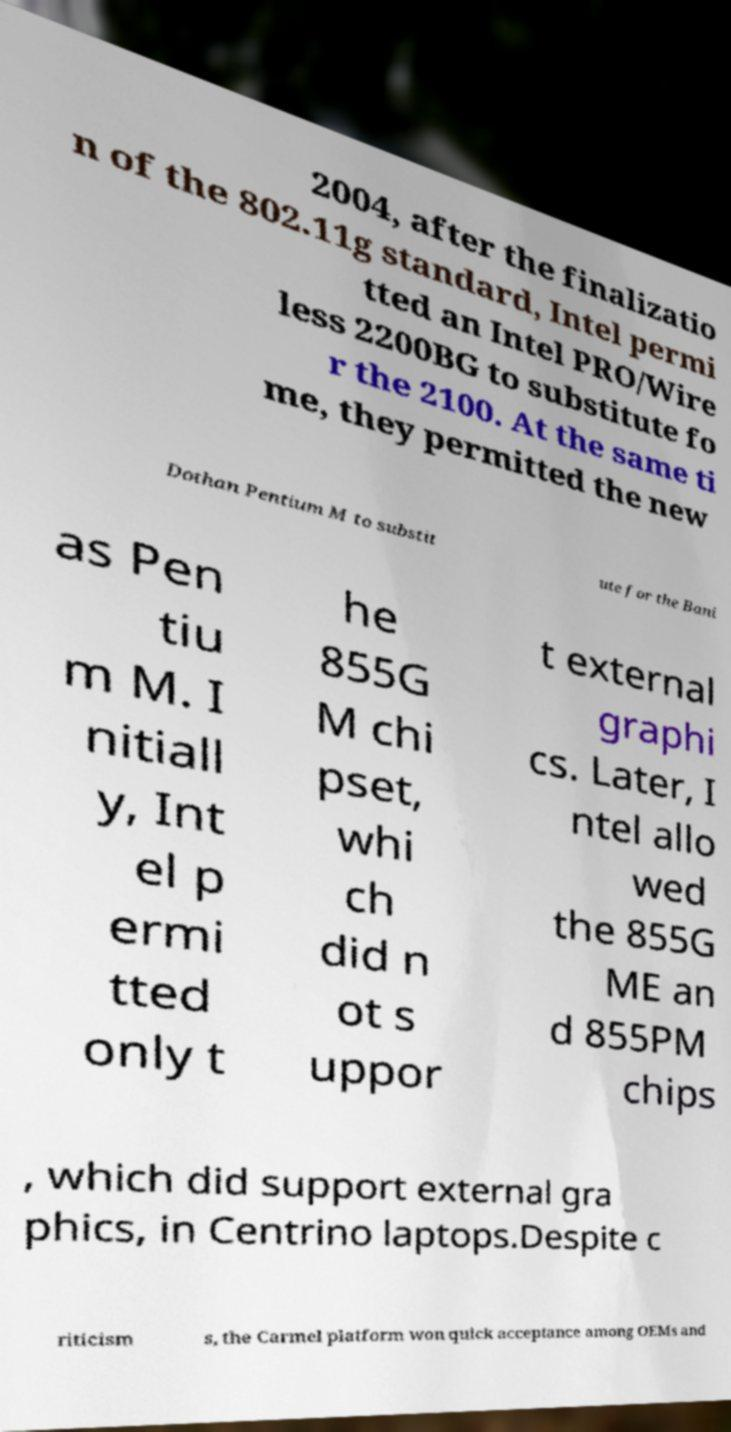Could you assist in decoding the text presented in this image and type it out clearly? 2004, after the finalizatio n of the 802.11g standard, Intel permi tted an Intel PRO/Wire less 2200BG to substitute fo r the 2100. At the same ti me, they permitted the new Dothan Pentium M to substit ute for the Bani as Pen tiu m M. I nitiall y, Int el p ermi tted only t he 855G M chi pset, whi ch did n ot s uppor t external graphi cs. Later, I ntel allo wed the 855G ME an d 855PM chips , which did support external gra phics, in Centrino laptops.Despite c riticism s, the Carmel platform won quick acceptance among OEMs and 